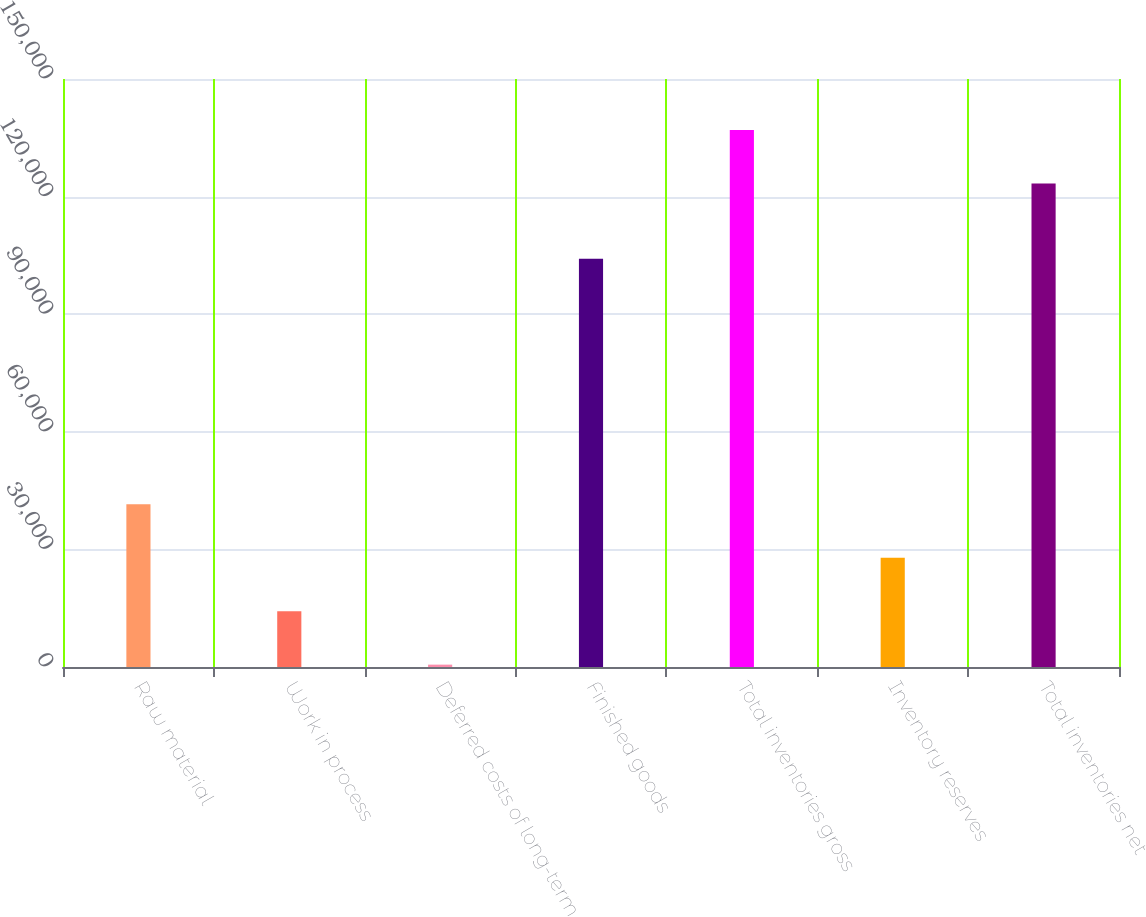Convert chart. <chart><loc_0><loc_0><loc_500><loc_500><bar_chart><fcel>Raw material<fcel>Work in process<fcel>Deferred costs of long-term<fcel>Finished goods<fcel>Total inventories gross<fcel>Inventory reserves<fcel>Total inventories net<nl><fcel>41526.4<fcel>14244.8<fcel>604<fcel>104137<fcel>137012<fcel>27885.6<fcel>123357<nl></chart> 